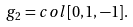Convert formula to latex. <formula><loc_0><loc_0><loc_500><loc_500>g _ { 2 } = c o l [ 0 , 1 , - 1 ] .</formula> 